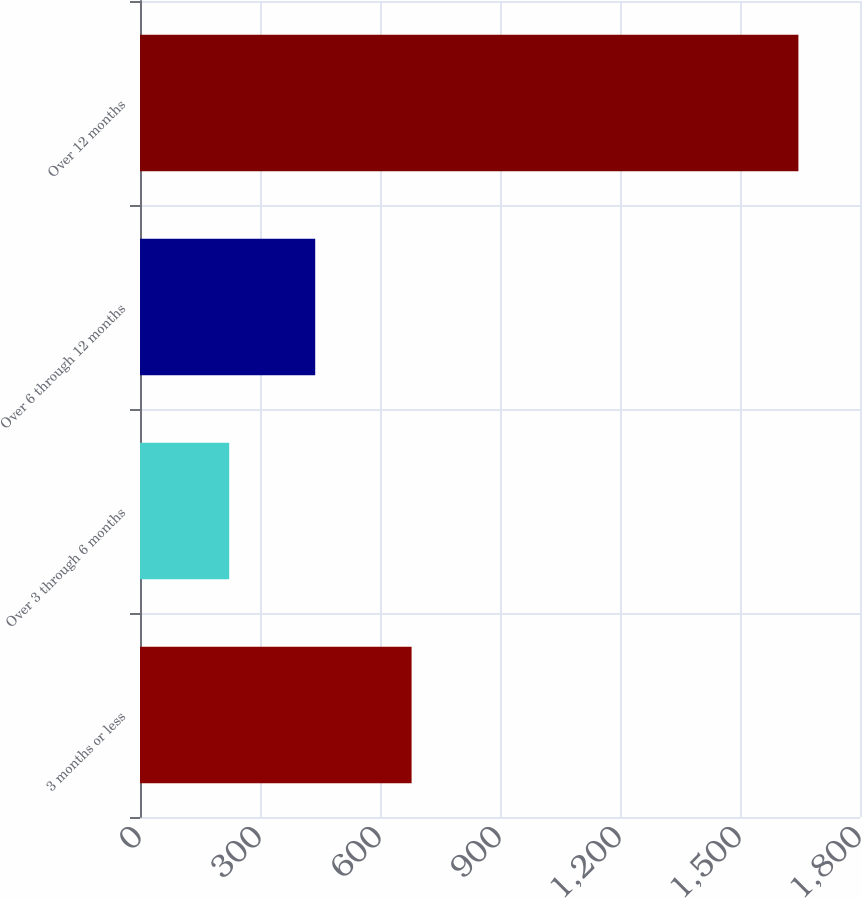<chart> <loc_0><loc_0><loc_500><loc_500><bar_chart><fcel>3 months or less<fcel>Over 3 through 6 months<fcel>Over 6 through 12 months<fcel>Over 12 months<nl><fcel>679<fcel>223<fcel>438<fcel>1646<nl></chart> 